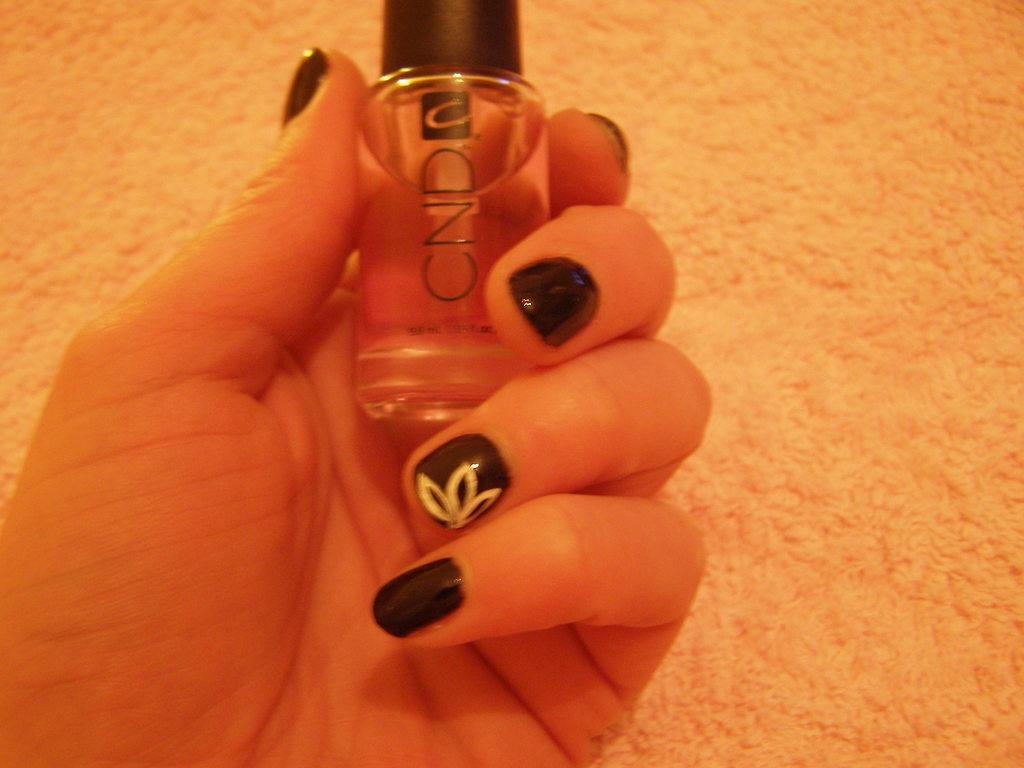Provide a one-sentence caption for the provided image. A women with black painted nails holding a bottle of CND nail polish. 